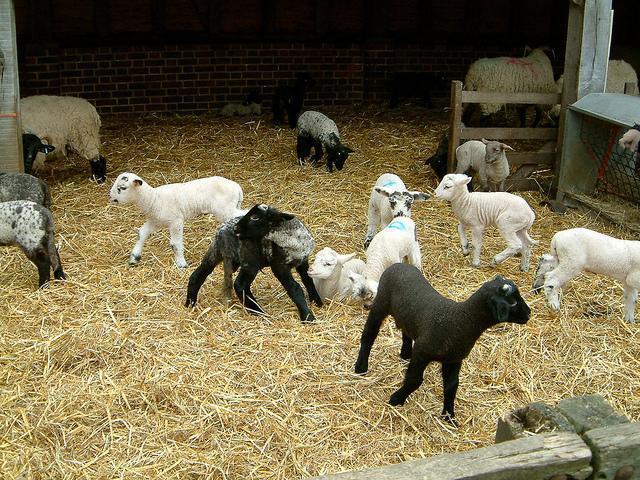How many white lambs are there?
Give a very brief answer. 6. How many black lambs?
Give a very brief answer. 3. How many sheep can be seen?
Give a very brief answer. 12. How many people are in the image?
Give a very brief answer. 0. 